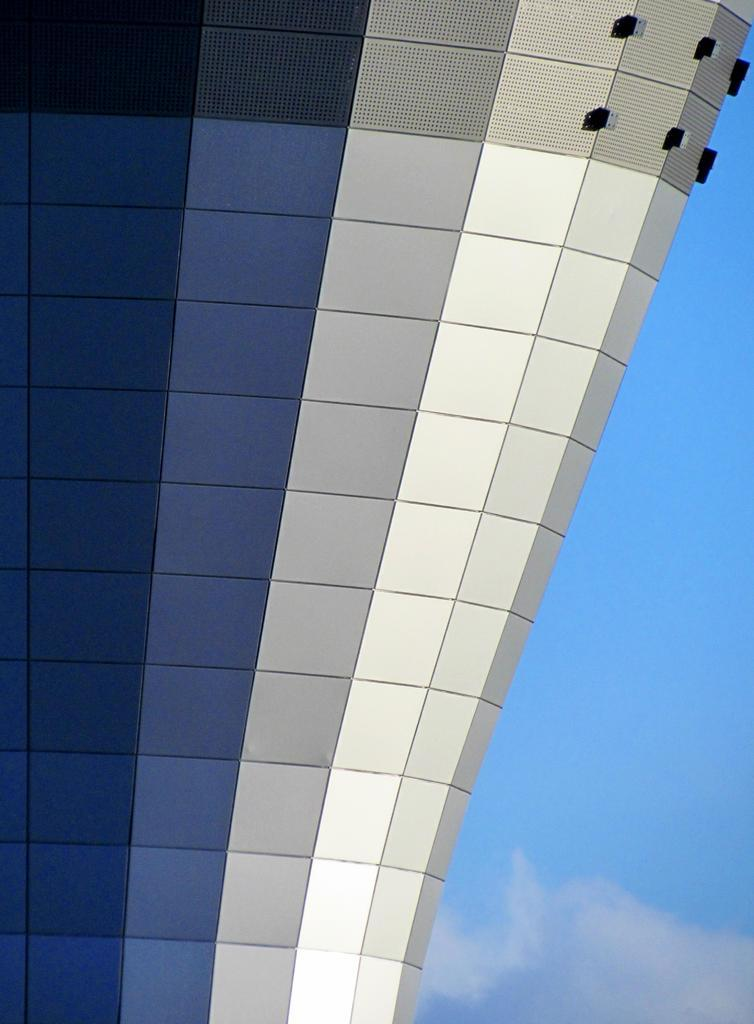What type of structure can be seen in the image? There is a building in the image. What part of the natural environment is visible in the image? The sky is visible in the image. What can be observed in the sky? Clouds are present in the sky. How many brothers are depicted in the image? There are no brothers present in the image; it features a building and clouds in the sky. What type of bird can be seen flying near the building in the image? There is no bird present in the image; it only features a building and clouds in the sky. 